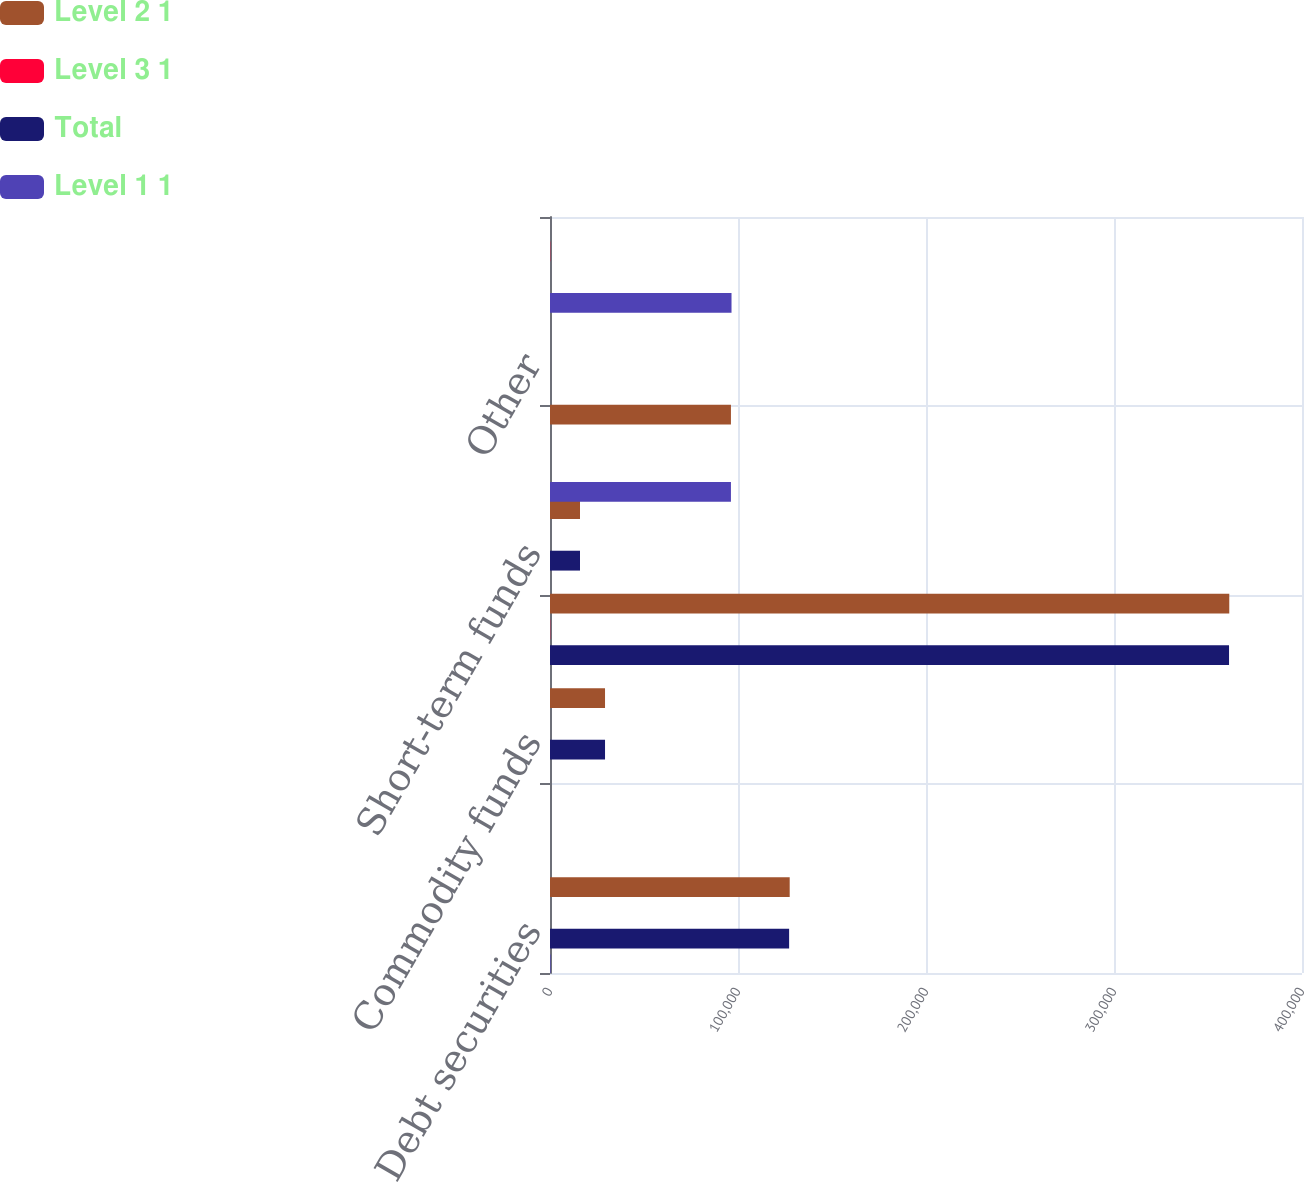<chart> <loc_0><loc_0><loc_500><loc_500><stacked_bar_chart><ecel><fcel>Debt securities<fcel>Bond funds<fcel>Commodity funds<fcel>Equity funds<fcel>Short-term funds<fcel>Venture capital and<fcel>Other<fcel>Total pension plan assets<nl><fcel>Level 2 1<fcel>127501<fcel>0<fcel>29270<fcel>361318<fcel>15967<fcel>96244<fcel>3<fcel>3<nl><fcel>Level 3 1<fcel>0<fcel>0<fcel>0<fcel>128<fcel>2<fcel>0<fcel>0<fcel>130<nl><fcel>Total<fcel>127193<fcel>0<fcel>29270<fcel>361190<fcel>15965<fcel>0<fcel>3<fcel>3<nl><fcel>Level 1 1<fcel>308<fcel>0<fcel>0<fcel>0<fcel>0<fcel>96244<fcel>0<fcel>96552<nl></chart> 